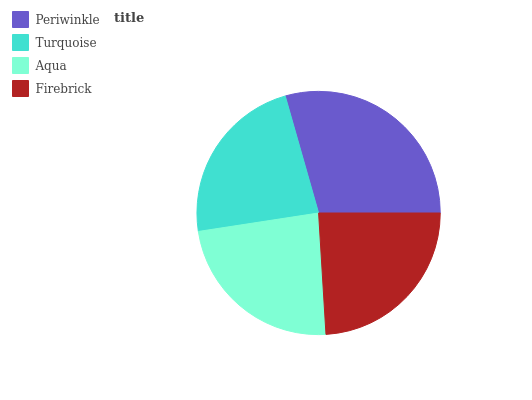Is Turquoise the minimum?
Answer yes or no. Yes. Is Periwinkle the maximum?
Answer yes or no. Yes. Is Aqua the minimum?
Answer yes or no. No. Is Aqua the maximum?
Answer yes or no. No. Is Aqua greater than Turquoise?
Answer yes or no. Yes. Is Turquoise less than Aqua?
Answer yes or no. Yes. Is Turquoise greater than Aqua?
Answer yes or no. No. Is Aqua less than Turquoise?
Answer yes or no. No. Is Firebrick the high median?
Answer yes or no. Yes. Is Aqua the low median?
Answer yes or no. Yes. Is Aqua the high median?
Answer yes or no. No. Is Turquoise the low median?
Answer yes or no. No. 